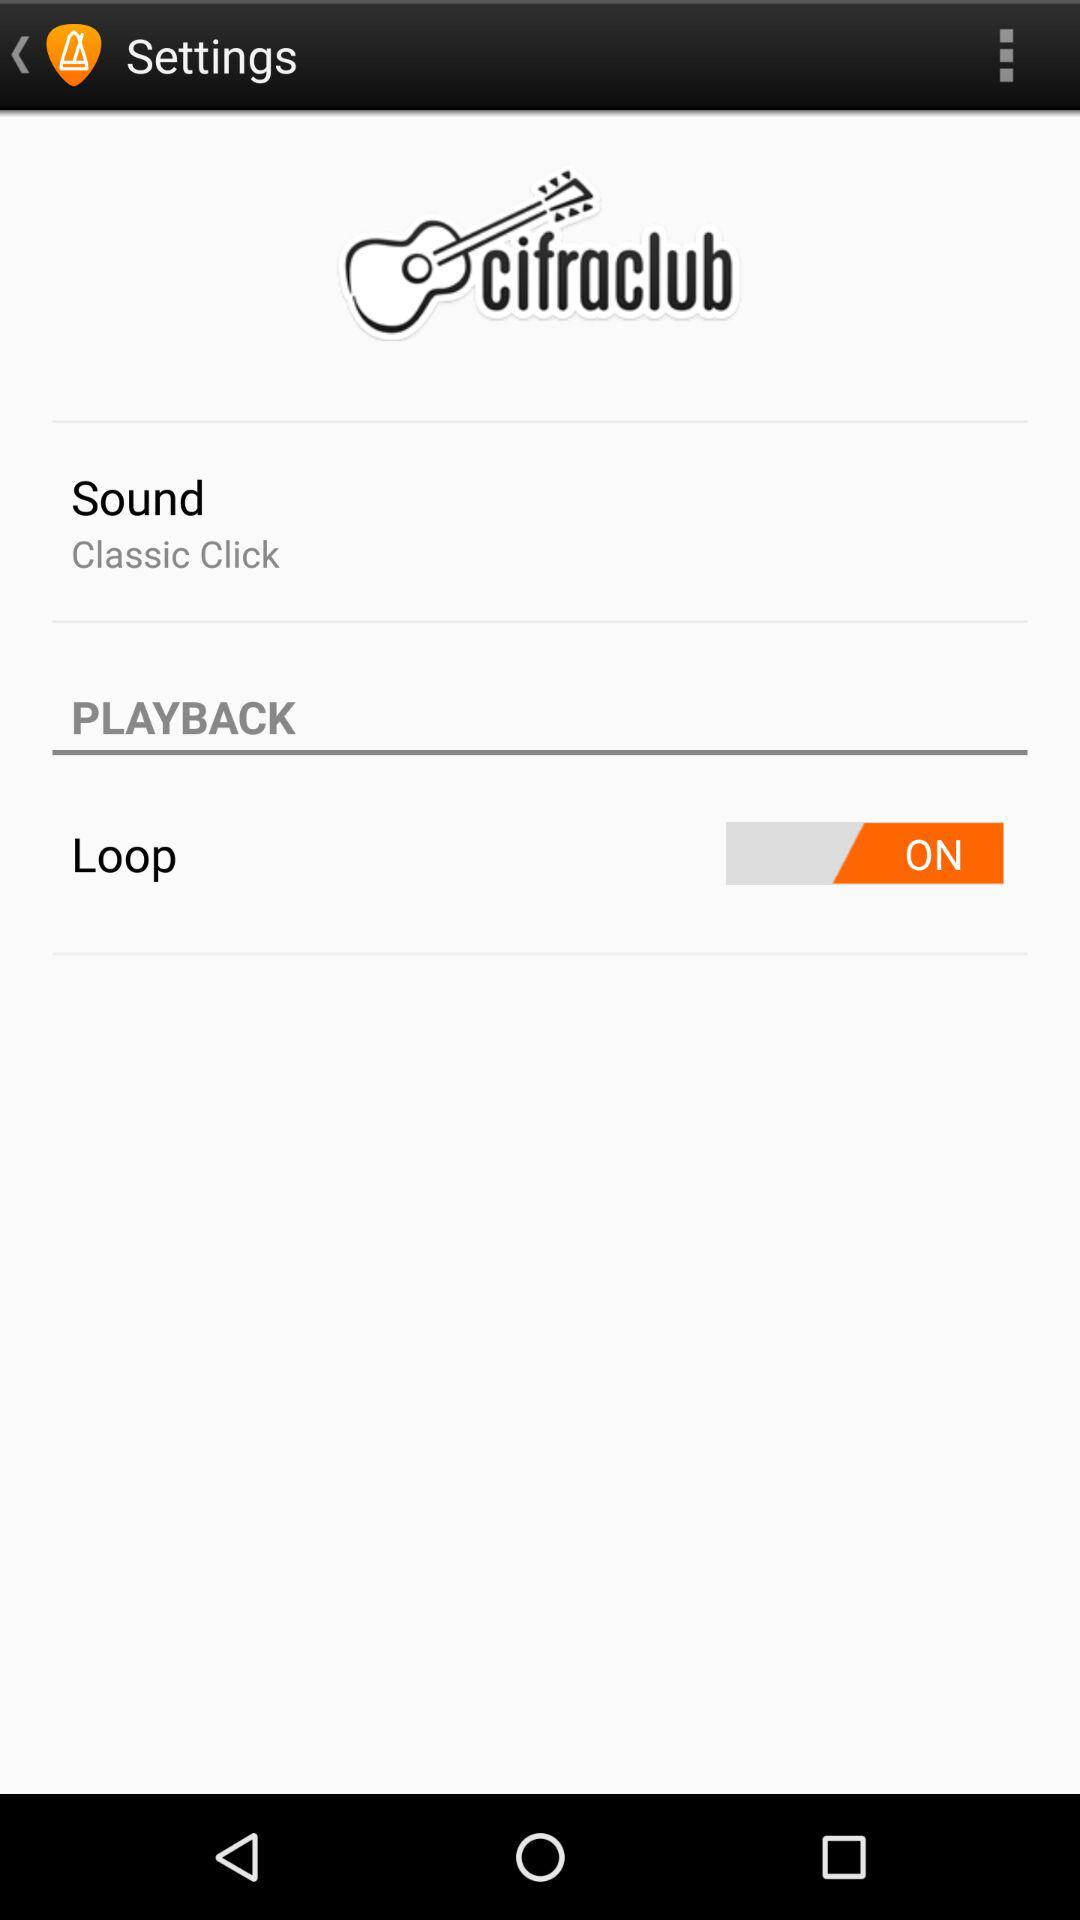What sound has been selected? The selected sound is the classic click. 